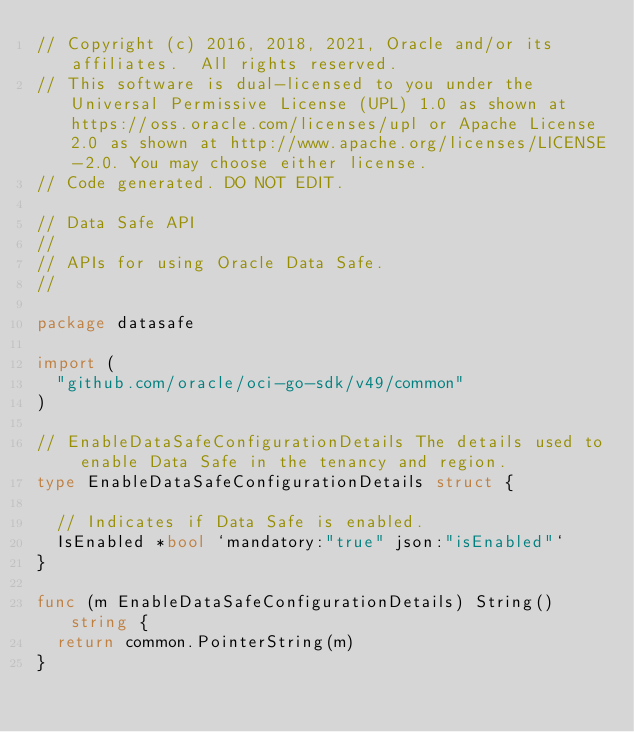<code> <loc_0><loc_0><loc_500><loc_500><_Go_>// Copyright (c) 2016, 2018, 2021, Oracle and/or its affiliates.  All rights reserved.
// This software is dual-licensed to you under the Universal Permissive License (UPL) 1.0 as shown at https://oss.oracle.com/licenses/upl or Apache License 2.0 as shown at http://www.apache.org/licenses/LICENSE-2.0. You may choose either license.
// Code generated. DO NOT EDIT.

// Data Safe API
//
// APIs for using Oracle Data Safe.
//

package datasafe

import (
	"github.com/oracle/oci-go-sdk/v49/common"
)

// EnableDataSafeConfigurationDetails The details used to enable Data Safe in the tenancy and region.
type EnableDataSafeConfigurationDetails struct {

	// Indicates if Data Safe is enabled.
	IsEnabled *bool `mandatory:"true" json:"isEnabled"`
}

func (m EnableDataSafeConfigurationDetails) String() string {
	return common.PointerString(m)
}
</code> 